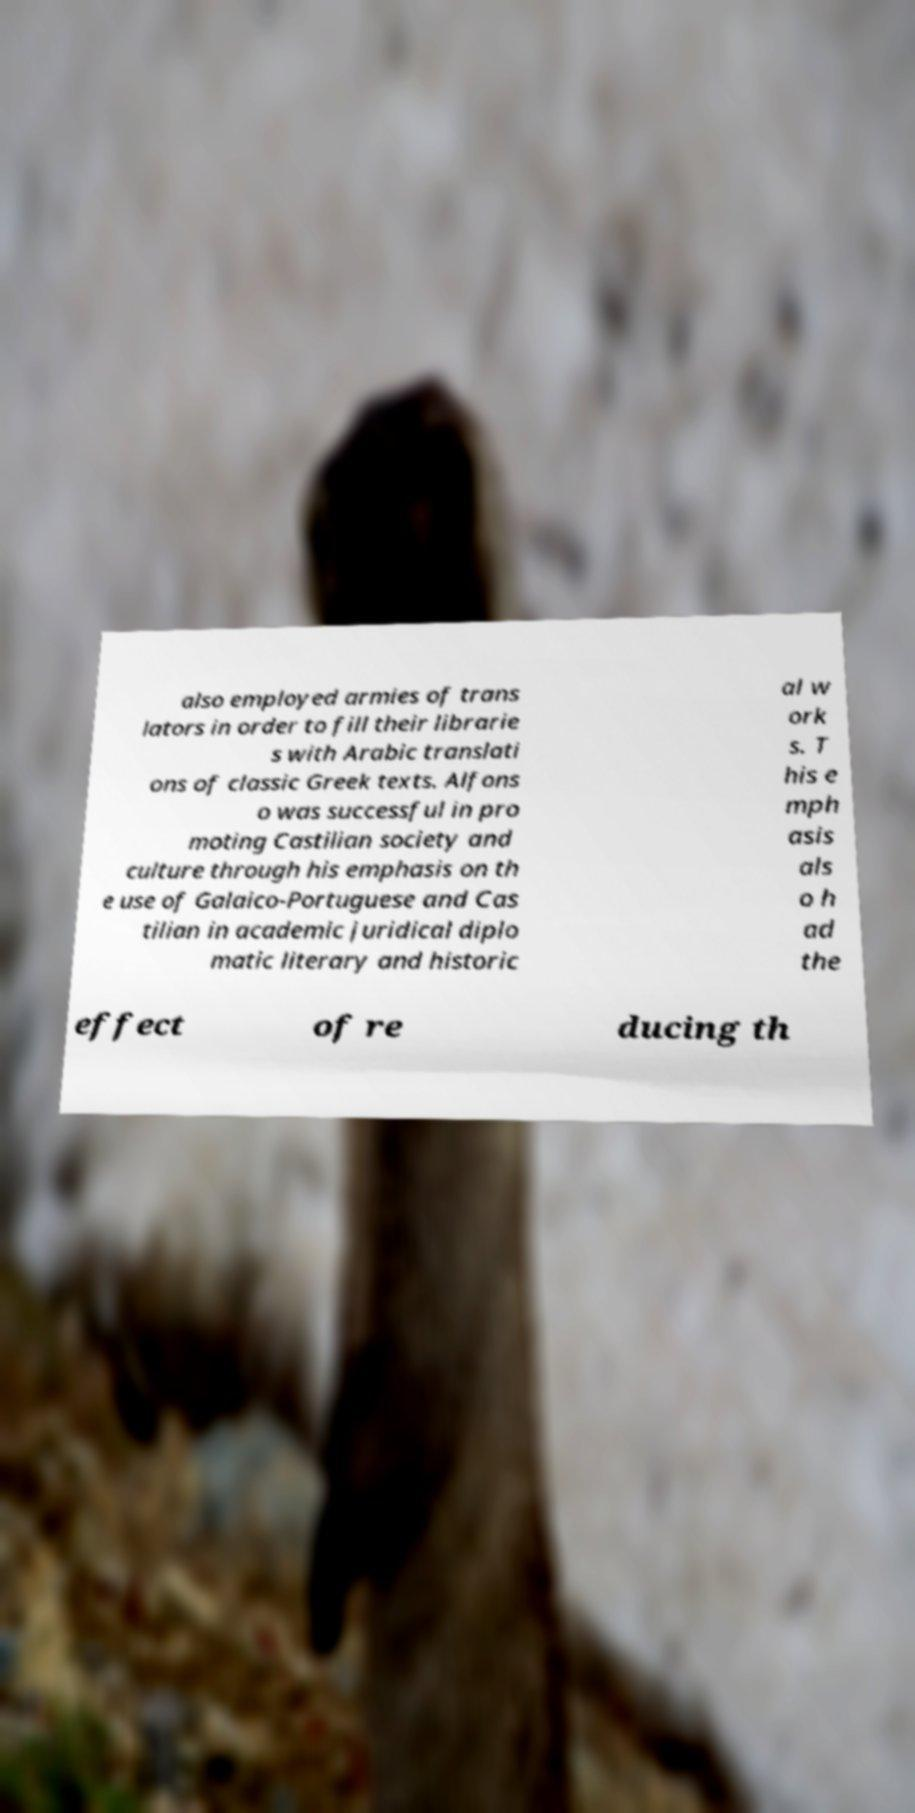Could you assist in decoding the text presented in this image and type it out clearly? also employed armies of trans lators in order to fill their librarie s with Arabic translati ons of classic Greek texts. Alfons o was successful in pro moting Castilian society and culture through his emphasis on th e use of Galaico-Portuguese and Cas tilian in academic juridical diplo matic literary and historic al w ork s. T his e mph asis als o h ad the effect of re ducing th 